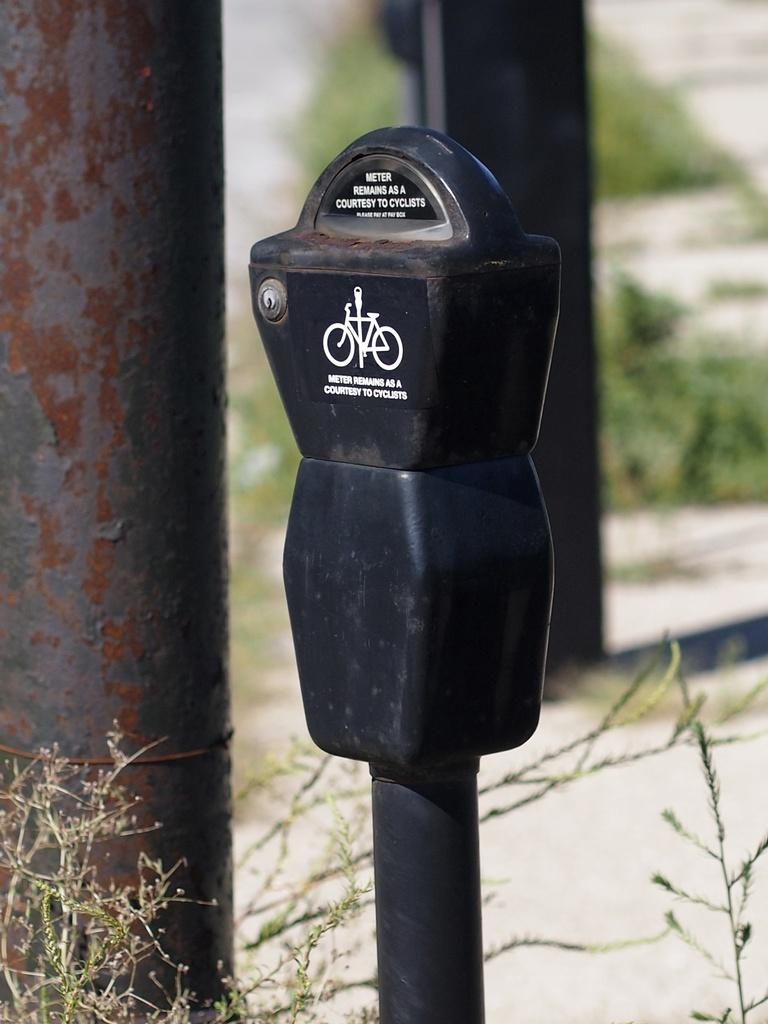<image>
Write a terse but informative summary of the picture. A beat up old parking meter that says it remains as a courtesy for cyclists. 